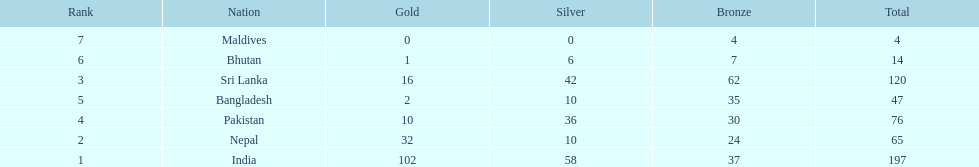Name the first country on the table? India. Parse the table in full. {'header': ['Rank', 'Nation', 'Gold', 'Silver', 'Bronze', 'Total'], 'rows': [['7', 'Maldives', '0', '0', '4', '4'], ['6', 'Bhutan', '1', '6', '7', '14'], ['3', 'Sri Lanka', '16', '42', '62', '120'], ['5', 'Bangladesh', '2', '10', '35', '47'], ['4', 'Pakistan', '10', '36', '30', '76'], ['2', 'Nepal', '32', '10', '24', '65'], ['1', 'India', '102', '58', '37', '197']]} 